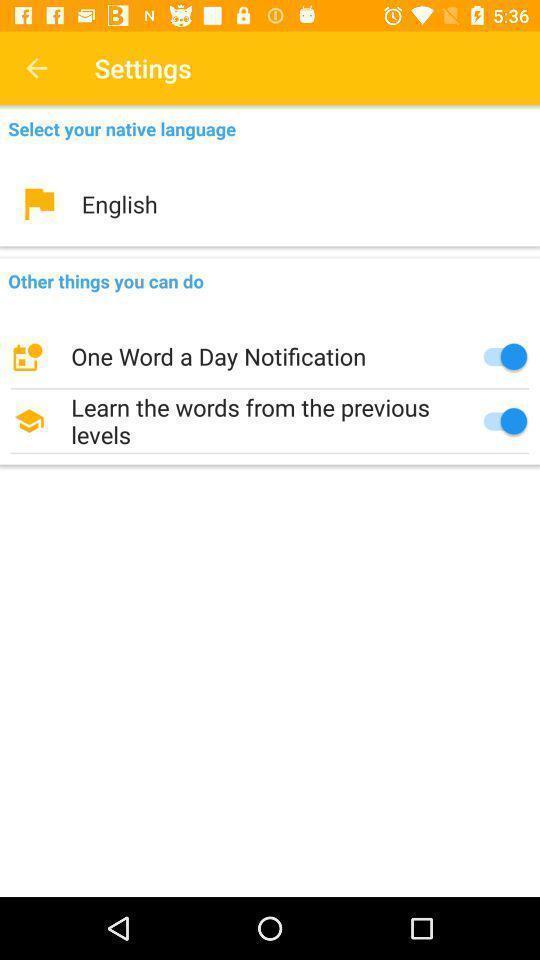Summarize the information in this screenshot. Settings page for the learning app. 